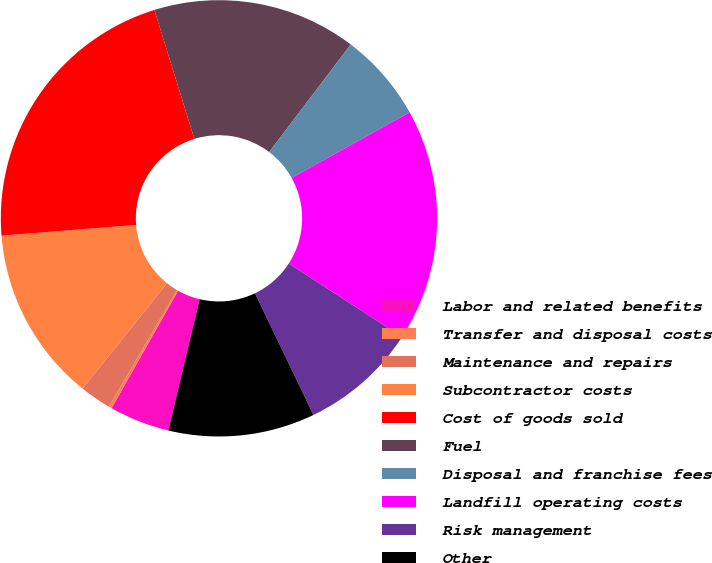Convert chart to OTSL. <chart><loc_0><loc_0><loc_500><loc_500><pie_chart><fcel>Labor and related benefits<fcel>Transfer and disposal costs<fcel>Maintenance and repairs<fcel>Subcontractor costs<fcel>Cost of goods sold<fcel>Fuel<fcel>Disposal and franchise fees<fcel>Landfill operating costs<fcel>Risk management<fcel>Other<nl><fcel>4.47%<fcel>0.22%<fcel>2.34%<fcel>12.98%<fcel>21.48%<fcel>15.1%<fcel>6.6%<fcel>17.23%<fcel>8.72%<fcel>10.85%<nl></chart> 